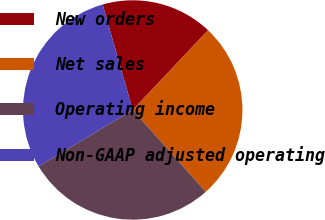Convert chart to OTSL. <chart><loc_0><loc_0><loc_500><loc_500><pie_chart><fcel>New orders<fcel>Net sales<fcel>Operating income<fcel>Non-GAAP adjusted operating<nl><fcel>16.47%<fcel>26.36%<fcel>28.01%<fcel>29.16%<nl></chart> 